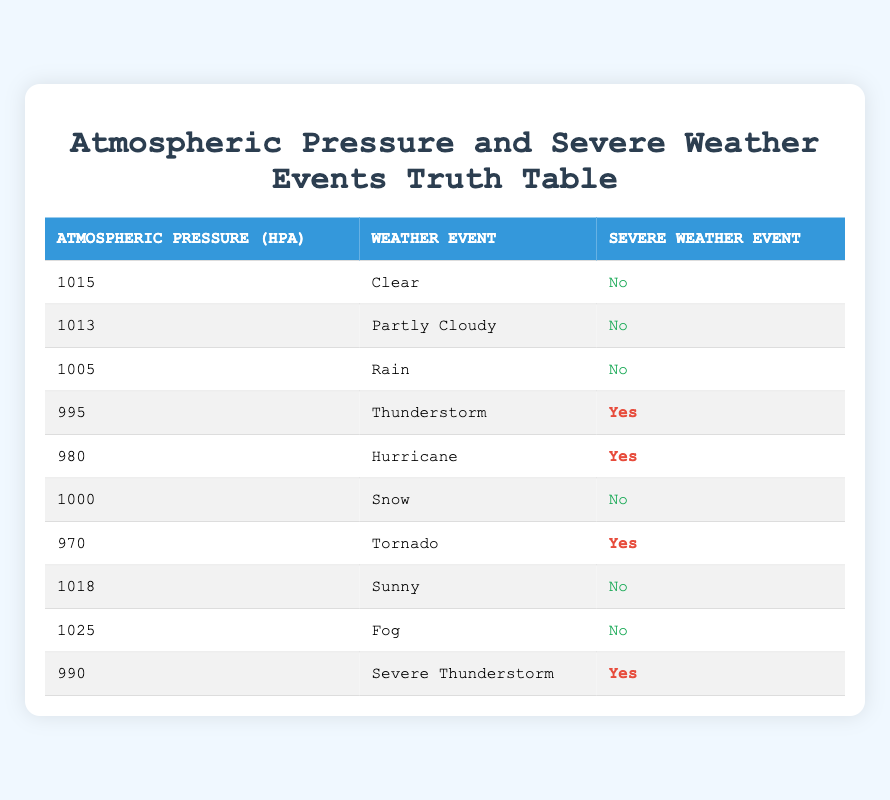What is the atmospheric pressure during a tornado event? The table lists a tornado event with an atmospheric pressure value of 970 hPa, which is found in the corresponding row for tornadoes.
Answer: 970 hPa How many severe weather events are indicated with a pressure below 1000 hPa? From the table, I count the events with pressures less than 1000 hPa, which are at 995 hPa (Thunderstorm), 980 hPa (Hurricane), 970 hPa (Tornado), and 990 hPa (Severe Thunderstorm). This results in a total of 4 events.
Answer: 4 Is a rain event associated with a severe weather event? The row for rain shows that the severe weather event is marked as "No," indicating that rain is not associated with severe weather conditions.
Answer: No What is the lowest atmospheric pressure recorded in a severe weather event? Reviewing the severe weather events, the lowest atmospheric pressure is found with the tornado, which has a pressure of 970 hPa. This is the smallest value across the severe weather categories in the table.
Answer: 970 hPa List all weather events associated with atmospheric pressure equal to or below 1000 hPa. From the table, the weather events corresponding to pressures of 1000 hPa or less are Rain (1005 hPa), Thunderstorm (995 hPa), Hurricane (980 hPa), Snow (1000 hPa), Tornado (970 hPa), and Severe Thunderstorm (990 hPa). This provides a total of 6 distinct weather events with pressures at or below 1000 hPa.
Answer: Rain, Thunderstorm, Hurricane, Snow, Tornado, Severe Thunderstorm What percentage of the events listed show a 'Yes' for severe weather under 1000 hPa pressure? The number of severe events under 1000 hPa is 4 (Thunderstorm, Hurricane, Tornado, Severe Thunderstorm), and the total number of all events in the table is 10. Thus, the calculation for percentage is (4/10)*100 = 40%.
Answer: 40% Are all events with an atmospheric pressure of 1015 hPa or higher associated with severe weather? Looking at the table, both weather events at 1015 hPa (Clear) and 1018 hPa (Sunny) indicate "No" for severe weather events. Therefore, it is confirmed that none of the events with pressures of 1015 hPa or higher are associated with severe weather events.
Answer: No What is the difference in atmospheric pressure between the highest and the lowest recorded weather events? The highest atmospheric pressure in the table is 1025 hPa (Fog), and the lowest is 970 hPa (Tornado). The difference is 1025 hPa - 970 hPa = 55 hPa.
Answer: 55 hPa Identify how many unique types of severe weather events are listed for atmospheric pressures under 1000 hPa. From the events with atmospheric pressures below 1000 hPa, the unique types of severe weather events are Thunderstorm, Hurricane, Tornado, and Severe Thunderstorm. This results in 4 unique types of severe weather events.
Answer: 4 